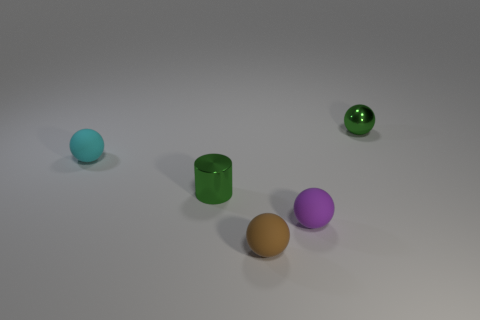Is there anything else that has the same color as the cylinder?
Make the answer very short. Yes. There is a cyan object that is the same material as the purple object; what is its size?
Make the answer very short. Small. What number of large objects are cyan balls or gray rubber spheres?
Your answer should be very brief. 0. There is a shiny thing right of the metal thing in front of the tiny cyan rubber thing that is behind the small green cylinder; how big is it?
Provide a short and direct response. Small. What number of cubes have the same size as the purple matte ball?
Your response must be concise. 0. What number of objects are small purple balls or small green things that are behind the small cyan matte ball?
Offer a very short reply. 2. The small brown rubber thing is what shape?
Your answer should be compact. Sphere. Does the metallic cylinder have the same color as the metal sphere?
Your response must be concise. Yes. What is the color of the cylinder that is the same size as the purple thing?
Offer a very short reply. Green. How many brown objects are either cylinders or small rubber objects?
Your response must be concise. 1. 